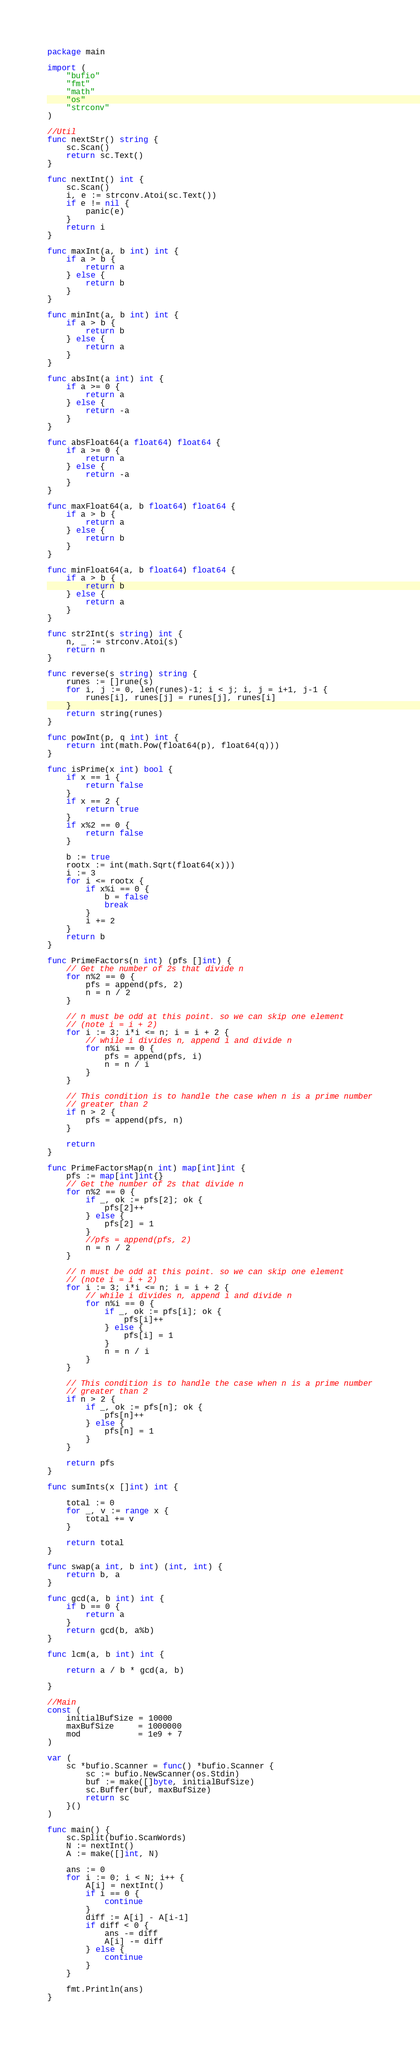<code> <loc_0><loc_0><loc_500><loc_500><_Go_>package main

import (
	"bufio"
	"fmt"
	"math"
	"os"
	"strconv"
)

//Util
func nextStr() string {
	sc.Scan()
	return sc.Text()
}

func nextInt() int {
	sc.Scan()
	i, e := strconv.Atoi(sc.Text())
	if e != nil {
		panic(e)
	}
	return i
}

func maxInt(a, b int) int {
	if a > b {
		return a
	} else {
		return b
	}
}

func minInt(a, b int) int {
	if a > b {
		return b
	} else {
		return a
	}
}

func absInt(a int) int {
	if a >= 0 {
		return a
	} else {
		return -a
	}
}

func absFloat64(a float64) float64 {
	if a >= 0 {
		return a
	} else {
		return -a
	}
}

func maxFloat64(a, b float64) float64 {
	if a > b {
		return a
	} else {
		return b
	}
}

func minFloat64(a, b float64) float64 {
	if a > b {
		return b
	} else {
		return a
	}
}

func str2Int(s string) int {
	n, _ := strconv.Atoi(s)
	return n
}

func reverse(s string) string {
	runes := []rune(s)
	for i, j := 0, len(runes)-1; i < j; i, j = i+1, j-1 {
		runes[i], runes[j] = runes[j], runes[i]
	}
	return string(runes)
}

func powInt(p, q int) int {
	return int(math.Pow(float64(p), float64(q)))
}

func isPrime(x int) bool {
	if x == 1 {
		return false
	}
	if x == 2 {
		return true
	}
	if x%2 == 0 {
		return false
	}

	b := true
	rootx := int(math.Sqrt(float64(x)))
	i := 3
	for i <= rootx {
		if x%i == 0 {
			b = false
			break
		}
		i += 2
	}
	return b
}

func PrimeFactors(n int) (pfs []int) {
	// Get the number of 2s that divide n
	for n%2 == 0 {
		pfs = append(pfs, 2)
		n = n / 2
	}

	// n must be odd at this point. so we can skip one element
	// (note i = i + 2)
	for i := 3; i*i <= n; i = i + 2 {
		// while i divides n, append i and divide n
		for n%i == 0 {
			pfs = append(pfs, i)
			n = n / i
		}
	}

	// This condition is to handle the case when n is a prime number
	// greater than 2
	if n > 2 {
		pfs = append(pfs, n)
	}

	return
}

func PrimeFactorsMap(n int) map[int]int {
	pfs := map[int]int{}
	// Get the number of 2s that divide n
	for n%2 == 0 {
		if _, ok := pfs[2]; ok {
			pfs[2]++
		} else {
			pfs[2] = 1
		}
		//pfs = append(pfs, 2)
		n = n / 2
	}

	// n must be odd at this point. so we can skip one element
	// (note i = i + 2)
	for i := 3; i*i <= n; i = i + 2 {
		// while i divides n, append i and divide n
		for n%i == 0 {
			if _, ok := pfs[i]; ok {
				pfs[i]++
			} else {
				pfs[i] = 1
			}
			n = n / i
		}
	}

	// This condition is to handle the case when n is a prime number
	// greater than 2
	if n > 2 {
		if _, ok := pfs[n]; ok {
			pfs[n]++
		} else {
			pfs[n] = 1
		}
	}

	return pfs
}

func sumInts(x []int) int {

	total := 0
	for _, v := range x {
		total += v
	}

	return total
}

func swap(a int, b int) (int, int) {
	return b, a
}

func gcd(a, b int) int {
	if b == 0 {
		return a
	}
	return gcd(b, a%b)
}

func lcm(a, b int) int {

	return a / b * gcd(a, b)

}

//Main
const (
	initialBufSize = 10000
	maxBufSize     = 1000000
	mod            = 1e9 + 7
)

var (
	sc *bufio.Scanner = func() *bufio.Scanner {
		sc := bufio.NewScanner(os.Stdin)
		buf := make([]byte, initialBufSize)
		sc.Buffer(buf, maxBufSize)
		return sc
	}()
)

func main() {
	sc.Split(bufio.ScanWords)
	N := nextInt()
	A := make([]int, N)

	ans := 0
	for i := 0; i < N; i++ {
		A[i] = nextInt()
		if i == 0 {
			continue
		}
		diff := A[i] - A[i-1]
		if diff < 0 {
			ans -= diff
			A[i] -= diff
		} else {
			continue
		}
	}

	fmt.Println(ans)
}
</code> 